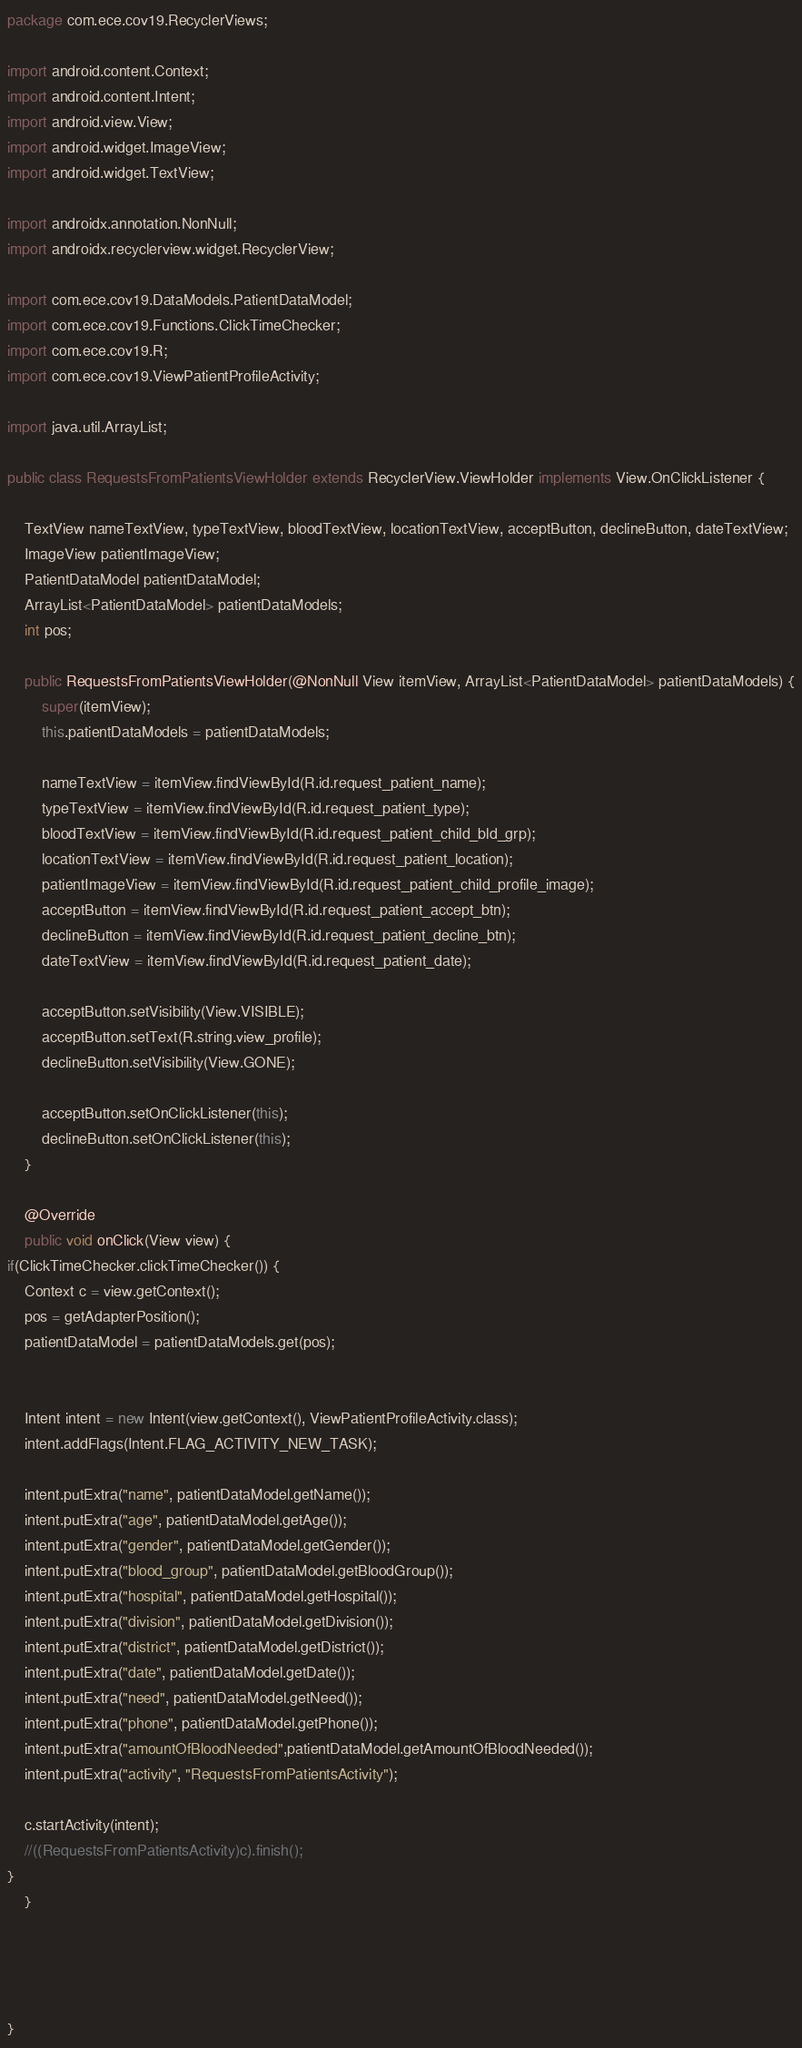<code> <loc_0><loc_0><loc_500><loc_500><_Java_>package com.ece.cov19.RecyclerViews;

import android.content.Context;
import android.content.Intent;
import android.view.View;
import android.widget.ImageView;
import android.widget.TextView;

import androidx.annotation.NonNull;
import androidx.recyclerview.widget.RecyclerView;

import com.ece.cov19.DataModels.PatientDataModel;
import com.ece.cov19.Functions.ClickTimeChecker;
import com.ece.cov19.R;
import com.ece.cov19.ViewPatientProfileActivity;

import java.util.ArrayList;

public class RequestsFromPatientsViewHolder extends RecyclerView.ViewHolder implements View.OnClickListener {

    TextView nameTextView, typeTextView, bloodTextView, locationTextView, acceptButton, declineButton, dateTextView;
    ImageView patientImageView;
    PatientDataModel patientDataModel;
    ArrayList<PatientDataModel> patientDataModels;
    int pos;

    public RequestsFromPatientsViewHolder(@NonNull View itemView, ArrayList<PatientDataModel> patientDataModels) {
        super(itemView);
        this.patientDataModels = patientDataModels;

        nameTextView = itemView.findViewById(R.id.request_patient_name);
        typeTextView = itemView.findViewById(R.id.request_patient_type);
        bloodTextView = itemView.findViewById(R.id.request_patient_child_bld_grp);
        locationTextView = itemView.findViewById(R.id.request_patient_location);
        patientImageView = itemView.findViewById(R.id.request_patient_child_profile_image);
        acceptButton = itemView.findViewById(R.id.request_patient_accept_btn);
        declineButton = itemView.findViewById(R.id.request_patient_decline_btn);
        dateTextView = itemView.findViewById(R.id.request_patient_date);

        acceptButton.setVisibility(View.VISIBLE);
        acceptButton.setText(R.string.view_profile);
        declineButton.setVisibility(View.GONE);

        acceptButton.setOnClickListener(this);
        declineButton.setOnClickListener(this);
    }

    @Override
    public void onClick(View view) {
if(ClickTimeChecker.clickTimeChecker()) {
    Context c = view.getContext();
    pos = getAdapterPosition();
    patientDataModel = patientDataModels.get(pos);


    Intent intent = new Intent(view.getContext(), ViewPatientProfileActivity.class);
    intent.addFlags(Intent.FLAG_ACTIVITY_NEW_TASK);

    intent.putExtra("name", patientDataModel.getName());
    intent.putExtra("age", patientDataModel.getAge());
    intent.putExtra("gender", patientDataModel.getGender());
    intent.putExtra("blood_group", patientDataModel.getBloodGroup());
    intent.putExtra("hospital", patientDataModel.getHospital());
    intent.putExtra("division", patientDataModel.getDivision());
    intent.putExtra("district", patientDataModel.getDistrict());
    intent.putExtra("date", patientDataModel.getDate());
    intent.putExtra("need", patientDataModel.getNeed());
    intent.putExtra("phone", patientDataModel.getPhone());
    intent.putExtra("amountOfBloodNeeded",patientDataModel.getAmountOfBloodNeeded());
    intent.putExtra("activity", "RequestsFromPatientsActivity");

    c.startActivity(intent);
    //((RequestsFromPatientsActivity)c).finish();
}
    }




}


</code> 